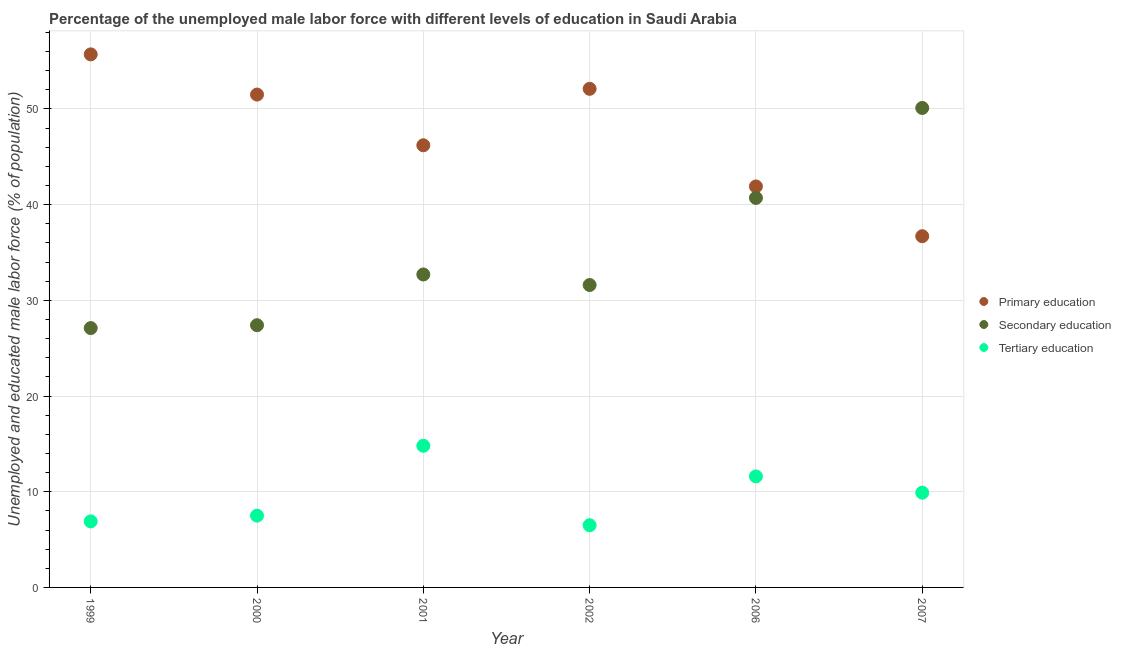What is the percentage of male labor force who received tertiary education in 1999?
Provide a short and direct response. 6.9. Across all years, what is the maximum percentage of male labor force who received primary education?
Your response must be concise. 55.7. Across all years, what is the minimum percentage of male labor force who received tertiary education?
Provide a short and direct response. 6.5. In which year was the percentage of male labor force who received secondary education maximum?
Offer a terse response. 2007. In which year was the percentage of male labor force who received primary education minimum?
Offer a terse response. 2007. What is the total percentage of male labor force who received tertiary education in the graph?
Give a very brief answer. 57.2. What is the difference between the percentage of male labor force who received secondary education in 2002 and that in 2006?
Offer a very short reply. -9.1. What is the average percentage of male labor force who received tertiary education per year?
Offer a terse response. 9.53. In the year 1999, what is the difference between the percentage of male labor force who received secondary education and percentage of male labor force who received tertiary education?
Provide a succinct answer. 20.2. In how many years, is the percentage of male labor force who received secondary education greater than 46 %?
Offer a terse response. 1. What is the ratio of the percentage of male labor force who received tertiary education in 1999 to that in 2007?
Provide a short and direct response. 0.7. Is the percentage of male labor force who received secondary education in 2000 less than that in 2006?
Provide a short and direct response. Yes. What is the difference between the highest and the second highest percentage of male labor force who received tertiary education?
Your answer should be very brief. 3.2. What is the difference between the highest and the lowest percentage of male labor force who received tertiary education?
Keep it short and to the point. 8.3. Is the sum of the percentage of male labor force who received primary education in 2001 and 2007 greater than the maximum percentage of male labor force who received tertiary education across all years?
Your answer should be very brief. Yes. Is the percentage of male labor force who received secondary education strictly greater than the percentage of male labor force who received tertiary education over the years?
Give a very brief answer. Yes. Is the percentage of male labor force who received primary education strictly less than the percentage of male labor force who received secondary education over the years?
Keep it short and to the point. No. How many years are there in the graph?
Offer a terse response. 6. Are the values on the major ticks of Y-axis written in scientific E-notation?
Your response must be concise. No. How many legend labels are there?
Provide a short and direct response. 3. What is the title of the graph?
Provide a short and direct response. Percentage of the unemployed male labor force with different levels of education in Saudi Arabia. What is the label or title of the Y-axis?
Offer a very short reply. Unemployed and educated male labor force (% of population). What is the Unemployed and educated male labor force (% of population) of Primary education in 1999?
Provide a succinct answer. 55.7. What is the Unemployed and educated male labor force (% of population) in Secondary education in 1999?
Offer a terse response. 27.1. What is the Unemployed and educated male labor force (% of population) of Tertiary education in 1999?
Your response must be concise. 6.9. What is the Unemployed and educated male labor force (% of population) in Primary education in 2000?
Offer a very short reply. 51.5. What is the Unemployed and educated male labor force (% of population) in Secondary education in 2000?
Make the answer very short. 27.4. What is the Unemployed and educated male labor force (% of population) in Primary education in 2001?
Keep it short and to the point. 46.2. What is the Unemployed and educated male labor force (% of population) of Secondary education in 2001?
Offer a very short reply. 32.7. What is the Unemployed and educated male labor force (% of population) of Tertiary education in 2001?
Your answer should be very brief. 14.8. What is the Unemployed and educated male labor force (% of population) in Primary education in 2002?
Provide a short and direct response. 52.1. What is the Unemployed and educated male labor force (% of population) in Secondary education in 2002?
Your answer should be compact. 31.6. What is the Unemployed and educated male labor force (% of population) of Tertiary education in 2002?
Provide a short and direct response. 6.5. What is the Unemployed and educated male labor force (% of population) of Primary education in 2006?
Offer a terse response. 41.9. What is the Unemployed and educated male labor force (% of population) in Secondary education in 2006?
Provide a short and direct response. 40.7. What is the Unemployed and educated male labor force (% of population) in Tertiary education in 2006?
Make the answer very short. 11.6. What is the Unemployed and educated male labor force (% of population) in Primary education in 2007?
Keep it short and to the point. 36.7. What is the Unemployed and educated male labor force (% of population) in Secondary education in 2007?
Your answer should be very brief. 50.1. What is the Unemployed and educated male labor force (% of population) of Tertiary education in 2007?
Provide a succinct answer. 9.9. Across all years, what is the maximum Unemployed and educated male labor force (% of population) of Primary education?
Your response must be concise. 55.7. Across all years, what is the maximum Unemployed and educated male labor force (% of population) of Secondary education?
Your answer should be compact. 50.1. Across all years, what is the maximum Unemployed and educated male labor force (% of population) in Tertiary education?
Your answer should be very brief. 14.8. Across all years, what is the minimum Unemployed and educated male labor force (% of population) of Primary education?
Your response must be concise. 36.7. Across all years, what is the minimum Unemployed and educated male labor force (% of population) of Secondary education?
Provide a succinct answer. 27.1. Across all years, what is the minimum Unemployed and educated male labor force (% of population) of Tertiary education?
Your answer should be very brief. 6.5. What is the total Unemployed and educated male labor force (% of population) of Primary education in the graph?
Provide a short and direct response. 284.1. What is the total Unemployed and educated male labor force (% of population) in Secondary education in the graph?
Give a very brief answer. 209.6. What is the total Unemployed and educated male labor force (% of population) in Tertiary education in the graph?
Your answer should be compact. 57.2. What is the difference between the Unemployed and educated male labor force (% of population) of Secondary education in 1999 and that in 2000?
Your answer should be compact. -0.3. What is the difference between the Unemployed and educated male labor force (% of population) in Tertiary education in 1999 and that in 2001?
Make the answer very short. -7.9. What is the difference between the Unemployed and educated male labor force (% of population) in Primary education in 1999 and that in 2006?
Make the answer very short. 13.8. What is the difference between the Unemployed and educated male labor force (% of population) in Secondary education in 1999 and that in 2006?
Your answer should be very brief. -13.6. What is the difference between the Unemployed and educated male labor force (% of population) of Secondary education in 1999 and that in 2007?
Your response must be concise. -23. What is the difference between the Unemployed and educated male labor force (% of population) in Tertiary education in 1999 and that in 2007?
Your answer should be very brief. -3. What is the difference between the Unemployed and educated male labor force (% of population) in Tertiary education in 2000 and that in 2001?
Offer a very short reply. -7.3. What is the difference between the Unemployed and educated male labor force (% of population) of Tertiary education in 2000 and that in 2002?
Make the answer very short. 1. What is the difference between the Unemployed and educated male labor force (% of population) in Tertiary education in 2000 and that in 2006?
Give a very brief answer. -4.1. What is the difference between the Unemployed and educated male labor force (% of population) in Primary education in 2000 and that in 2007?
Make the answer very short. 14.8. What is the difference between the Unemployed and educated male labor force (% of population) in Secondary education in 2000 and that in 2007?
Offer a very short reply. -22.7. What is the difference between the Unemployed and educated male labor force (% of population) in Tertiary education in 2000 and that in 2007?
Ensure brevity in your answer.  -2.4. What is the difference between the Unemployed and educated male labor force (% of population) in Secondary education in 2001 and that in 2002?
Offer a terse response. 1.1. What is the difference between the Unemployed and educated male labor force (% of population) of Primary education in 2001 and that in 2006?
Keep it short and to the point. 4.3. What is the difference between the Unemployed and educated male labor force (% of population) of Primary education in 2001 and that in 2007?
Your response must be concise. 9.5. What is the difference between the Unemployed and educated male labor force (% of population) in Secondary education in 2001 and that in 2007?
Make the answer very short. -17.4. What is the difference between the Unemployed and educated male labor force (% of population) in Tertiary education in 2001 and that in 2007?
Your answer should be compact. 4.9. What is the difference between the Unemployed and educated male labor force (% of population) of Secondary education in 2002 and that in 2007?
Offer a very short reply. -18.5. What is the difference between the Unemployed and educated male labor force (% of population) of Tertiary education in 2002 and that in 2007?
Ensure brevity in your answer.  -3.4. What is the difference between the Unemployed and educated male labor force (% of population) of Primary education in 2006 and that in 2007?
Offer a very short reply. 5.2. What is the difference between the Unemployed and educated male labor force (% of population) in Tertiary education in 2006 and that in 2007?
Offer a very short reply. 1.7. What is the difference between the Unemployed and educated male labor force (% of population) in Primary education in 1999 and the Unemployed and educated male labor force (% of population) in Secondary education in 2000?
Your answer should be compact. 28.3. What is the difference between the Unemployed and educated male labor force (% of population) of Primary education in 1999 and the Unemployed and educated male labor force (% of population) of Tertiary education in 2000?
Keep it short and to the point. 48.2. What is the difference between the Unemployed and educated male labor force (% of population) of Secondary education in 1999 and the Unemployed and educated male labor force (% of population) of Tertiary education in 2000?
Provide a succinct answer. 19.6. What is the difference between the Unemployed and educated male labor force (% of population) of Primary education in 1999 and the Unemployed and educated male labor force (% of population) of Tertiary education in 2001?
Your answer should be compact. 40.9. What is the difference between the Unemployed and educated male labor force (% of population) of Primary education in 1999 and the Unemployed and educated male labor force (% of population) of Secondary education in 2002?
Offer a terse response. 24.1. What is the difference between the Unemployed and educated male labor force (% of population) of Primary education in 1999 and the Unemployed and educated male labor force (% of population) of Tertiary education in 2002?
Your answer should be compact. 49.2. What is the difference between the Unemployed and educated male labor force (% of population) of Secondary education in 1999 and the Unemployed and educated male labor force (% of population) of Tertiary education in 2002?
Ensure brevity in your answer.  20.6. What is the difference between the Unemployed and educated male labor force (% of population) of Primary education in 1999 and the Unemployed and educated male labor force (% of population) of Secondary education in 2006?
Offer a very short reply. 15. What is the difference between the Unemployed and educated male labor force (% of population) in Primary education in 1999 and the Unemployed and educated male labor force (% of population) in Tertiary education in 2006?
Your answer should be compact. 44.1. What is the difference between the Unemployed and educated male labor force (% of population) of Secondary education in 1999 and the Unemployed and educated male labor force (% of population) of Tertiary education in 2006?
Keep it short and to the point. 15.5. What is the difference between the Unemployed and educated male labor force (% of population) in Primary education in 1999 and the Unemployed and educated male labor force (% of population) in Secondary education in 2007?
Offer a very short reply. 5.6. What is the difference between the Unemployed and educated male labor force (% of population) in Primary education in 1999 and the Unemployed and educated male labor force (% of population) in Tertiary education in 2007?
Your answer should be very brief. 45.8. What is the difference between the Unemployed and educated male labor force (% of population) in Secondary education in 1999 and the Unemployed and educated male labor force (% of population) in Tertiary education in 2007?
Keep it short and to the point. 17.2. What is the difference between the Unemployed and educated male labor force (% of population) of Primary education in 2000 and the Unemployed and educated male labor force (% of population) of Tertiary education in 2001?
Provide a short and direct response. 36.7. What is the difference between the Unemployed and educated male labor force (% of population) in Primary education in 2000 and the Unemployed and educated male labor force (% of population) in Secondary education in 2002?
Provide a succinct answer. 19.9. What is the difference between the Unemployed and educated male labor force (% of population) in Secondary education in 2000 and the Unemployed and educated male labor force (% of population) in Tertiary education in 2002?
Provide a short and direct response. 20.9. What is the difference between the Unemployed and educated male labor force (% of population) in Primary education in 2000 and the Unemployed and educated male labor force (% of population) in Tertiary education in 2006?
Offer a terse response. 39.9. What is the difference between the Unemployed and educated male labor force (% of population) in Primary education in 2000 and the Unemployed and educated male labor force (% of population) in Tertiary education in 2007?
Provide a succinct answer. 41.6. What is the difference between the Unemployed and educated male labor force (% of population) of Primary education in 2001 and the Unemployed and educated male labor force (% of population) of Secondary education in 2002?
Offer a terse response. 14.6. What is the difference between the Unemployed and educated male labor force (% of population) of Primary education in 2001 and the Unemployed and educated male labor force (% of population) of Tertiary education in 2002?
Your response must be concise. 39.7. What is the difference between the Unemployed and educated male labor force (% of population) of Secondary education in 2001 and the Unemployed and educated male labor force (% of population) of Tertiary education in 2002?
Provide a short and direct response. 26.2. What is the difference between the Unemployed and educated male labor force (% of population) in Primary education in 2001 and the Unemployed and educated male labor force (% of population) in Secondary education in 2006?
Provide a short and direct response. 5.5. What is the difference between the Unemployed and educated male labor force (% of population) of Primary education in 2001 and the Unemployed and educated male labor force (% of population) of Tertiary education in 2006?
Your response must be concise. 34.6. What is the difference between the Unemployed and educated male labor force (% of population) of Secondary education in 2001 and the Unemployed and educated male labor force (% of population) of Tertiary education in 2006?
Your answer should be compact. 21.1. What is the difference between the Unemployed and educated male labor force (% of population) in Primary education in 2001 and the Unemployed and educated male labor force (% of population) in Tertiary education in 2007?
Keep it short and to the point. 36.3. What is the difference between the Unemployed and educated male labor force (% of population) of Secondary education in 2001 and the Unemployed and educated male labor force (% of population) of Tertiary education in 2007?
Your response must be concise. 22.8. What is the difference between the Unemployed and educated male labor force (% of population) in Primary education in 2002 and the Unemployed and educated male labor force (% of population) in Tertiary education in 2006?
Make the answer very short. 40.5. What is the difference between the Unemployed and educated male labor force (% of population) of Primary education in 2002 and the Unemployed and educated male labor force (% of population) of Secondary education in 2007?
Make the answer very short. 2. What is the difference between the Unemployed and educated male labor force (% of population) in Primary education in 2002 and the Unemployed and educated male labor force (% of population) in Tertiary education in 2007?
Make the answer very short. 42.2. What is the difference between the Unemployed and educated male labor force (% of population) of Secondary education in 2002 and the Unemployed and educated male labor force (% of population) of Tertiary education in 2007?
Your response must be concise. 21.7. What is the difference between the Unemployed and educated male labor force (% of population) of Primary education in 2006 and the Unemployed and educated male labor force (% of population) of Secondary education in 2007?
Give a very brief answer. -8.2. What is the difference between the Unemployed and educated male labor force (% of population) in Secondary education in 2006 and the Unemployed and educated male labor force (% of population) in Tertiary education in 2007?
Make the answer very short. 30.8. What is the average Unemployed and educated male labor force (% of population) in Primary education per year?
Provide a short and direct response. 47.35. What is the average Unemployed and educated male labor force (% of population) of Secondary education per year?
Keep it short and to the point. 34.93. What is the average Unemployed and educated male labor force (% of population) in Tertiary education per year?
Ensure brevity in your answer.  9.53. In the year 1999, what is the difference between the Unemployed and educated male labor force (% of population) in Primary education and Unemployed and educated male labor force (% of population) in Secondary education?
Make the answer very short. 28.6. In the year 1999, what is the difference between the Unemployed and educated male labor force (% of population) of Primary education and Unemployed and educated male labor force (% of population) of Tertiary education?
Offer a very short reply. 48.8. In the year 1999, what is the difference between the Unemployed and educated male labor force (% of population) of Secondary education and Unemployed and educated male labor force (% of population) of Tertiary education?
Your answer should be compact. 20.2. In the year 2000, what is the difference between the Unemployed and educated male labor force (% of population) of Primary education and Unemployed and educated male labor force (% of population) of Secondary education?
Offer a very short reply. 24.1. In the year 2000, what is the difference between the Unemployed and educated male labor force (% of population) of Primary education and Unemployed and educated male labor force (% of population) of Tertiary education?
Keep it short and to the point. 44. In the year 2001, what is the difference between the Unemployed and educated male labor force (% of population) of Primary education and Unemployed and educated male labor force (% of population) of Tertiary education?
Provide a succinct answer. 31.4. In the year 2001, what is the difference between the Unemployed and educated male labor force (% of population) in Secondary education and Unemployed and educated male labor force (% of population) in Tertiary education?
Ensure brevity in your answer.  17.9. In the year 2002, what is the difference between the Unemployed and educated male labor force (% of population) of Primary education and Unemployed and educated male labor force (% of population) of Tertiary education?
Your answer should be very brief. 45.6. In the year 2002, what is the difference between the Unemployed and educated male labor force (% of population) of Secondary education and Unemployed and educated male labor force (% of population) of Tertiary education?
Offer a very short reply. 25.1. In the year 2006, what is the difference between the Unemployed and educated male labor force (% of population) of Primary education and Unemployed and educated male labor force (% of population) of Tertiary education?
Your answer should be very brief. 30.3. In the year 2006, what is the difference between the Unemployed and educated male labor force (% of population) of Secondary education and Unemployed and educated male labor force (% of population) of Tertiary education?
Provide a short and direct response. 29.1. In the year 2007, what is the difference between the Unemployed and educated male labor force (% of population) of Primary education and Unemployed and educated male labor force (% of population) of Tertiary education?
Your answer should be very brief. 26.8. In the year 2007, what is the difference between the Unemployed and educated male labor force (% of population) in Secondary education and Unemployed and educated male labor force (% of population) in Tertiary education?
Offer a terse response. 40.2. What is the ratio of the Unemployed and educated male labor force (% of population) of Primary education in 1999 to that in 2000?
Provide a succinct answer. 1.08. What is the ratio of the Unemployed and educated male labor force (% of population) of Secondary education in 1999 to that in 2000?
Provide a succinct answer. 0.99. What is the ratio of the Unemployed and educated male labor force (% of population) of Tertiary education in 1999 to that in 2000?
Offer a terse response. 0.92. What is the ratio of the Unemployed and educated male labor force (% of population) in Primary education in 1999 to that in 2001?
Offer a very short reply. 1.21. What is the ratio of the Unemployed and educated male labor force (% of population) of Secondary education in 1999 to that in 2001?
Your response must be concise. 0.83. What is the ratio of the Unemployed and educated male labor force (% of population) in Tertiary education in 1999 to that in 2001?
Your response must be concise. 0.47. What is the ratio of the Unemployed and educated male labor force (% of population) in Primary education in 1999 to that in 2002?
Offer a terse response. 1.07. What is the ratio of the Unemployed and educated male labor force (% of population) of Secondary education in 1999 to that in 2002?
Provide a succinct answer. 0.86. What is the ratio of the Unemployed and educated male labor force (% of population) of Tertiary education in 1999 to that in 2002?
Ensure brevity in your answer.  1.06. What is the ratio of the Unemployed and educated male labor force (% of population) in Primary education in 1999 to that in 2006?
Provide a succinct answer. 1.33. What is the ratio of the Unemployed and educated male labor force (% of population) of Secondary education in 1999 to that in 2006?
Your answer should be compact. 0.67. What is the ratio of the Unemployed and educated male labor force (% of population) of Tertiary education in 1999 to that in 2006?
Your answer should be compact. 0.59. What is the ratio of the Unemployed and educated male labor force (% of population) of Primary education in 1999 to that in 2007?
Your answer should be very brief. 1.52. What is the ratio of the Unemployed and educated male labor force (% of population) of Secondary education in 1999 to that in 2007?
Your response must be concise. 0.54. What is the ratio of the Unemployed and educated male labor force (% of population) of Tertiary education in 1999 to that in 2007?
Your answer should be very brief. 0.7. What is the ratio of the Unemployed and educated male labor force (% of population) in Primary education in 2000 to that in 2001?
Your answer should be compact. 1.11. What is the ratio of the Unemployed and educated male labor force (% of population) in Secondary education in 2000 to that in 2001?
Your answer should be compact. 0.84. What is the ratio of the Unemployed and educated male labor force (% of population) in Tertiary education in 2000 to that in 2001?
Your answer should be compact. 0.51. What is the ratio of the Unemployed and educated male labor force (% of population) of Secondary education in 2000 to that in 2002?
Offer a terse response. 0.87. What is the ratio of the Unemployed and educated male labor force (% of population) of Tertiary education in 2000 to that in 2002?
Provide a short and direct response. 1.15. What is the ratio of the Unemployed and educated male labor force (% of population) of Primary education in 2000 to that in 2006?
Provide a short and direct response. 1.23. What is the ratio of the Unemployed and educated male labor force (% of population) of Secondary education in 2000 to that in 2006?
Your answer should be very brief. 0.67. What is the ratio of the Unemployed and educated male labor force (% of population) of Tertiary education in 2000 to that in 2006?
Ensure brevity in your answer.  0.65. What is the ratio of the Unemployed and educated male labor force (% of population) of Primary education in 2000 to that in 2007?
Give a very brief answer. 1.4. What is the ratio of the Unemployed and educated male labor force (% of population) in Secondary education in 2000 to that in 2007?
Offer a very short reply. 0.55. What is the ratio of the Unemployed and educated male labor force (% of population) of Tertiary education in 2000 to that in 2007?
Offer a very short reply. 0.76. What is the ratio of the Unemployed and educated male labor force (% of population) of Primary education in 2001 to that in 2002?
Keep it short and to the point. 0.89. What is the ratio of the Unemployed and educated male labor force (% of population) of Secondary education in 2001 to that in 2002?
Give a very brief answer. 1.03. What is the ratio of the Unemployed and educated male labor force (% of population) of Tertiary education in 2001 to that in 2002?
Your answer should be compact. 2.28. What is the ratio of the Unemployed and educated male labor force (% of population) of Primary education in 2001 to that in 2006?
Make the answer very short. 1.1. What is the ratio of the Unemployed and educated male labor force (% of population) in Secondary education in 2001 to that in 2006?
Offer a very short reply. 0.8. What is the ratio of the Unemployed and educated male labor force (% of population) in Tertiary education in 2001 to that in 2006?
Give a very brief answer. 1.28. What is the ratio of the Unemployed and educated male labor force (% of population) of Primary education in 2001 to that in 2007?
Give a very brief answer. 1.26. What is the ratio of the Unemployed and educated male labor force (% of population) in Secondary education in 2001 to that in 2007?
Give a very brief answer. 0.65. What is the ratio of the Unemployed and educated male labor force (% of population) in Tertiary education in 2001 to that in 2007?
Provide a short and direct response. 1.49. What is the ratio of the Unemployed and educated male labor force (% of population) in Primary education in 2002 to that in 2006?
Your answer should be very brief. 1.24. What is the ratio of the Unemployed and educated male labor force (% of population) of Secondary education in 2002 to that in 2006?
Your answer should be compact. 0.78. What is the ratio of the Unemployed and educated male labor force (% of population) of Tertiary education in 2002 to that in 2006?
Ensure brevity in your answer.  0.56. What is the ratio of the Unemployed and educated male labor force (% of population) in Primary education in 2002 to that in 2007?
Offer a very short reply. 1.42. What is the ratio of the Unemployed and educated male labor force (% of population) of Secondary education in 2002 to that in 2007?
Offer a very short reply. 0.63. What is the ratio of the Unemployed and educated male labor force (% of population) of Tertiary education in 2002 to that in 2007?
Make the answer very short. 0.66. What is the ratio of the Unemployed and educated male labor force (% of population) of Primary education in 2006 to that in 2007?
Provide a succinct answer. 1.14. What is the ratio of the Unemployed and educated male labor force (% of population) in Secondary education in 2006 to that in 2007?
Make the answer very short. 0.81. What is the ratio of the Unemployed and educated male labor force (% of population) in Tertiary education in 2006 to that in 2007?
Give a very brief answer. 1.17. What is the difference between the highest and the second highest Unemployed and educated male labor force (% of population) in Primary education?
Provide a succinct answer. 3.6. What is the difference between the highest and the second highest Unemployed and educated male labor force (% of population) in Tertiary education?
Keep it short and to the point. 3.2. What is the difference between the highest and the lowest Unemployed and educated male labor force (% of population) of Secondary education?
Your answer should be very brief. 23. 